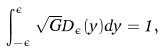<formula> <loc_0><loc_0><loc_500><loc_500>\int _ { - \epsilon } ^ { \epsilon } \sqrt { G } D _ { \epsilon } ( y ) d y = 1 ,</formula> 